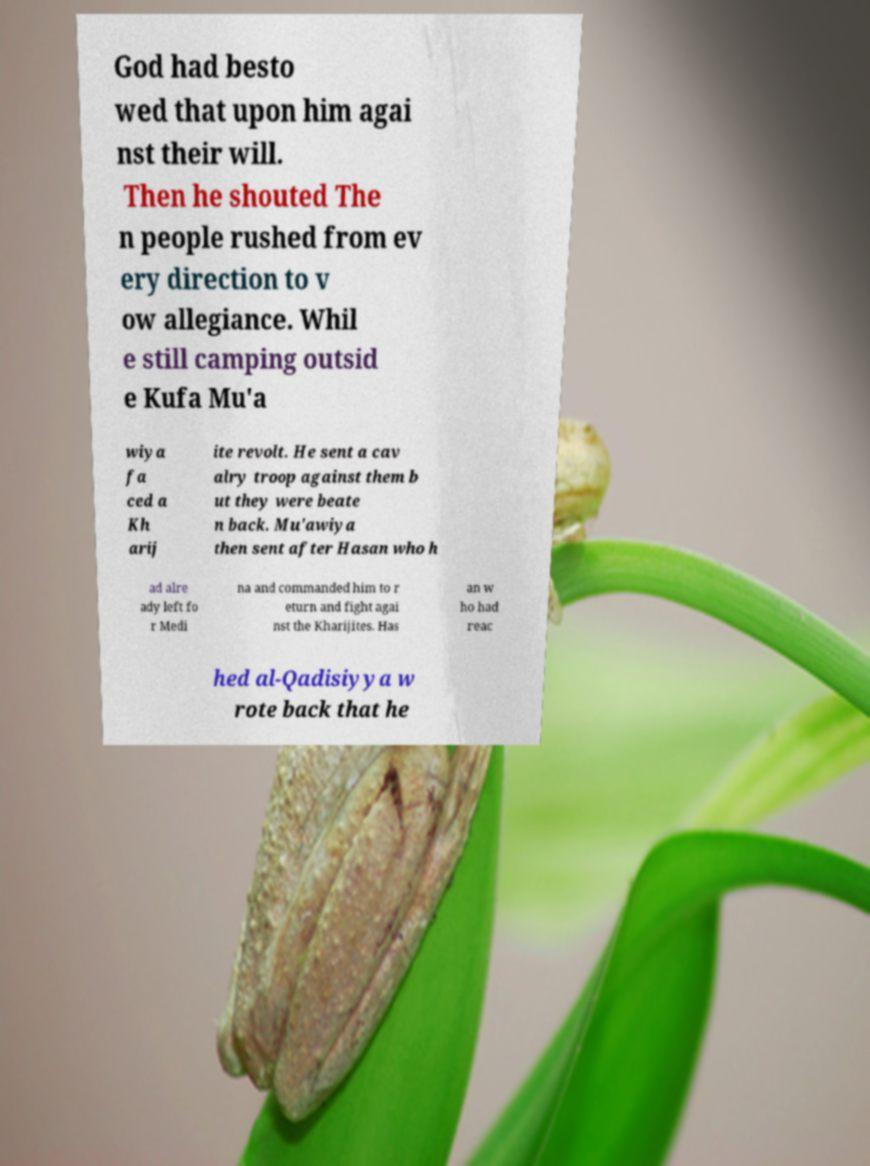There's text embedded in this image that I need extracted. Can you transcribe it verbatim? God had besto wed that upon him agai nst their will. Then he shouted The n people rushed from ev ery direction to v ow allegiance. Whil e still camping outsid e Kufa Mu'a wiya fa ced a Kh arij ite revolt. He sent a cav alry troop against them b ut they were beate n back. Mu'awiya then sent after Hasan who h ad alre ady left fo r Medi na and commanded him to r eturn and fight agai nst the Kharijites. Has an w ho had reac hed al-Qadisiyya w rote back that he 